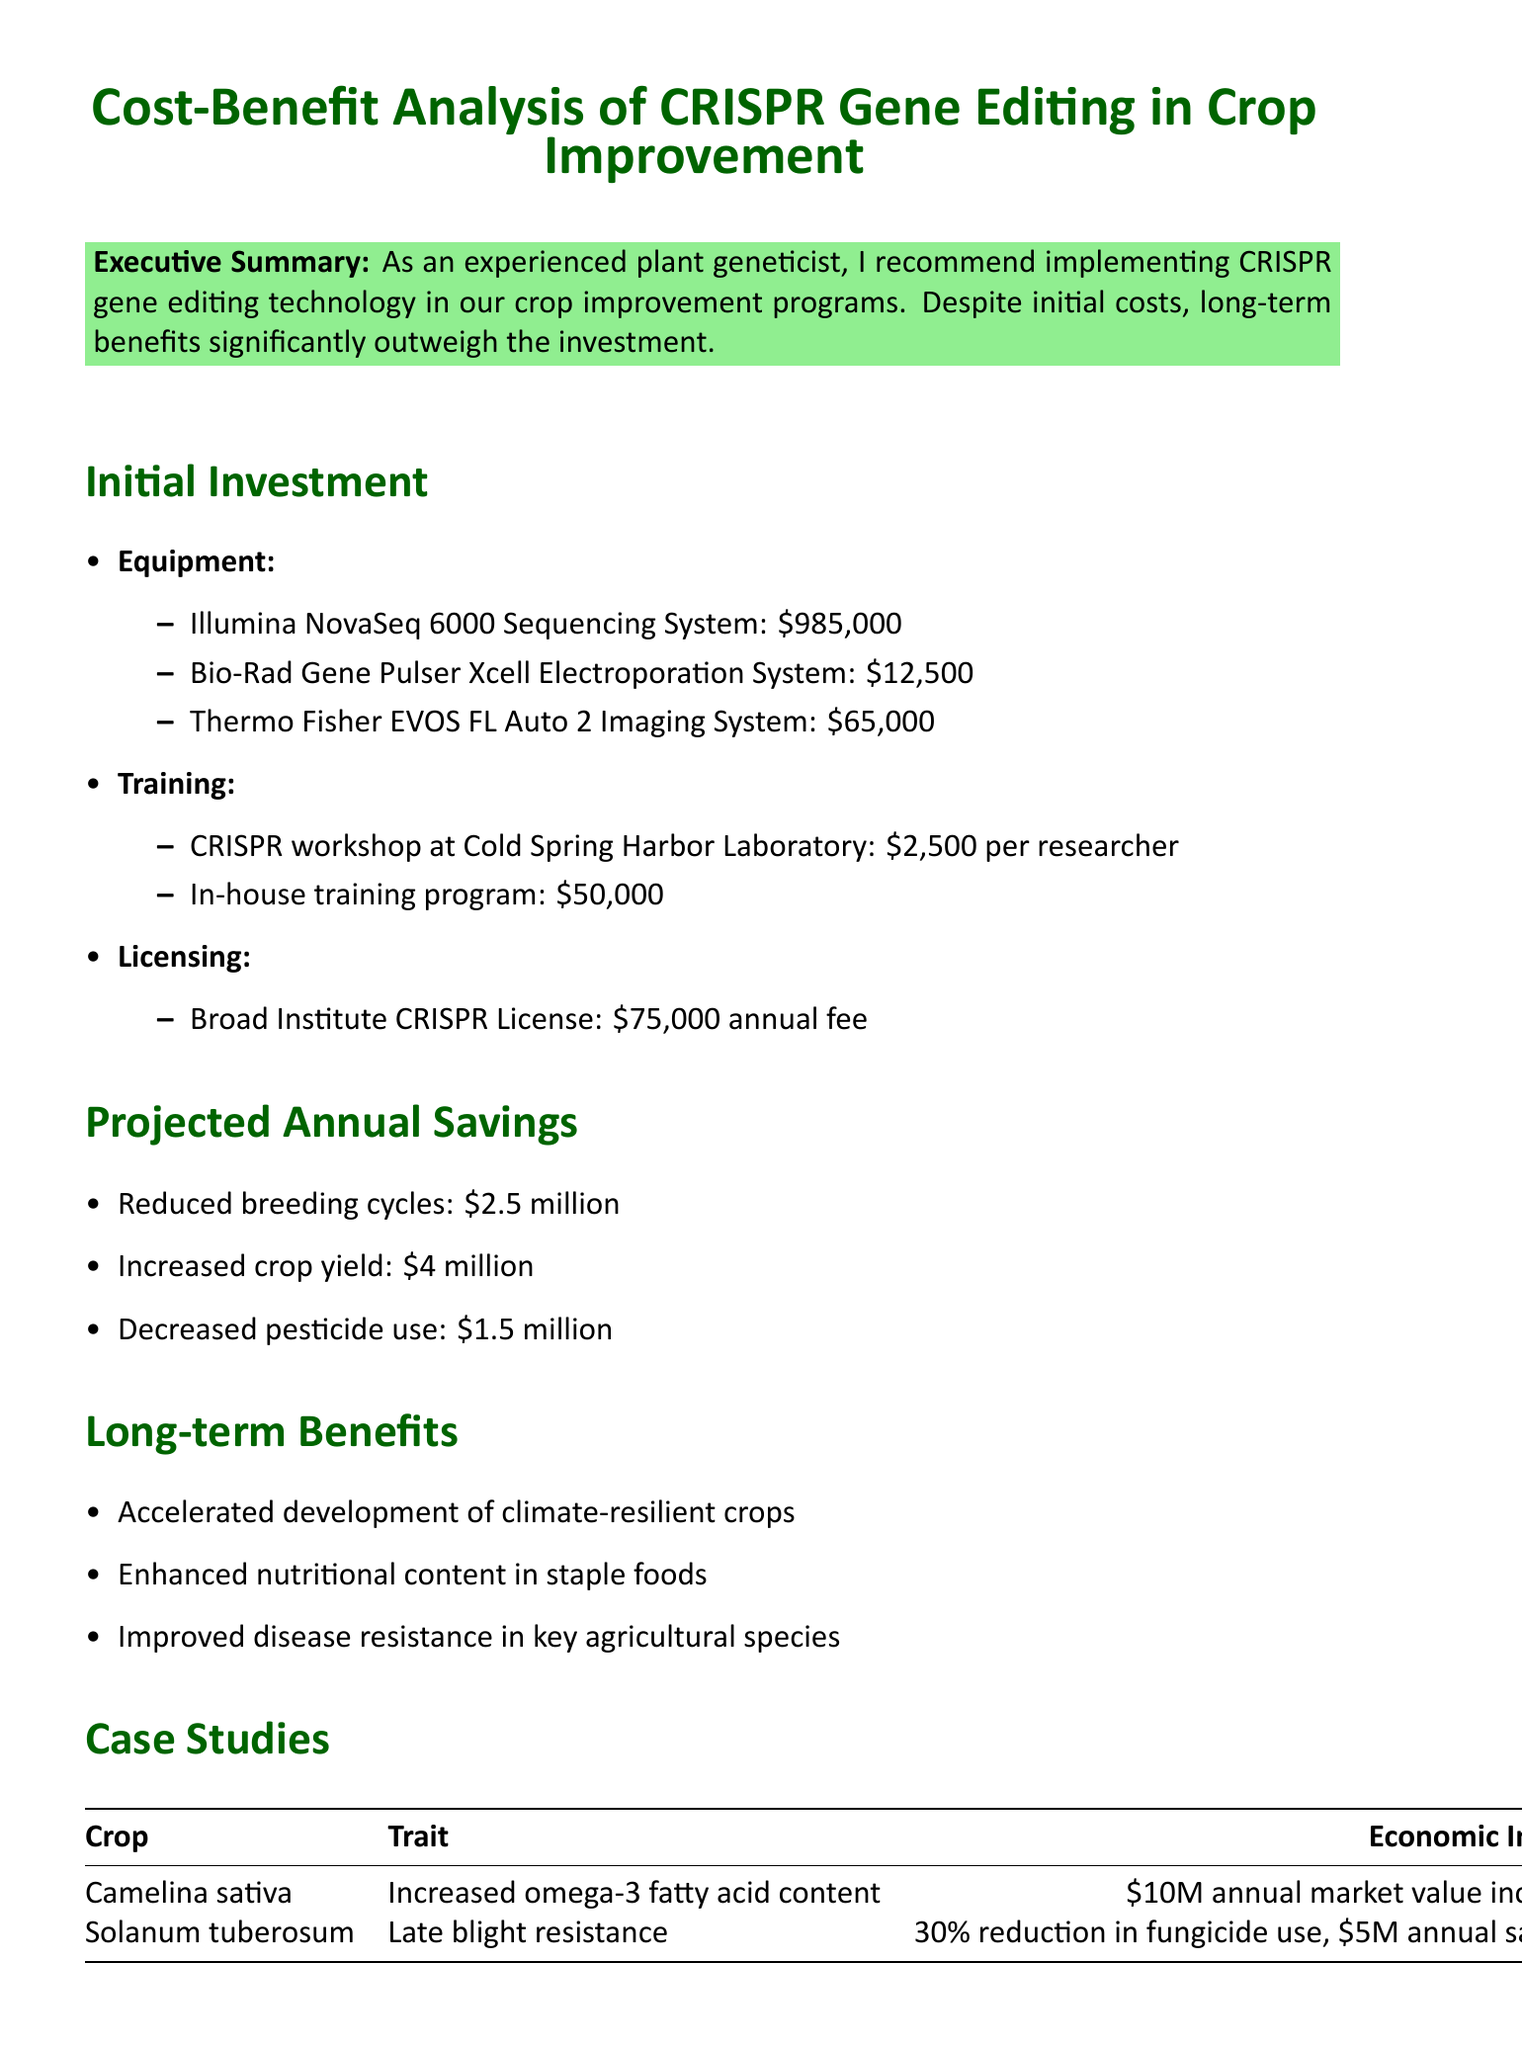What is the title of the report? The title of the report is stated at the beginning of the document.
Answer: Cost-Benefit Analysis of CRISPR Gene Editing in Crop Improvement What is the initial investment for the Illumina NovaSeq 6000 Sequencing System? The initial investment amount for this specific equipment is provided in the investments section.
Answer: $985,000 How much can be saved annually by reducing breeding cycles? This information is mentioned under projected annual savings in the document.
Answer: $2.5 million What are the long-term benefits listed in the report? The report describes several advantages that will result from implementing CRISPR technology.
Answer: Accelerated development of climate-resilient crops, Enhanced nutritional content in staple foods, Improved disease resistance in key agricultural species What is the economic impact of the late blight resistance in Solanum tuberosum? The case studies section details the economic effects of specific traits in crops.
Answer: 30% reduction in fungicide use, saving $5 million annually What type of challenges are mentioned in the risk assessment? The document specifies types of challenges faced during implementation in the risk assessment section.
Answer: Regulatory challenges, Public perception 